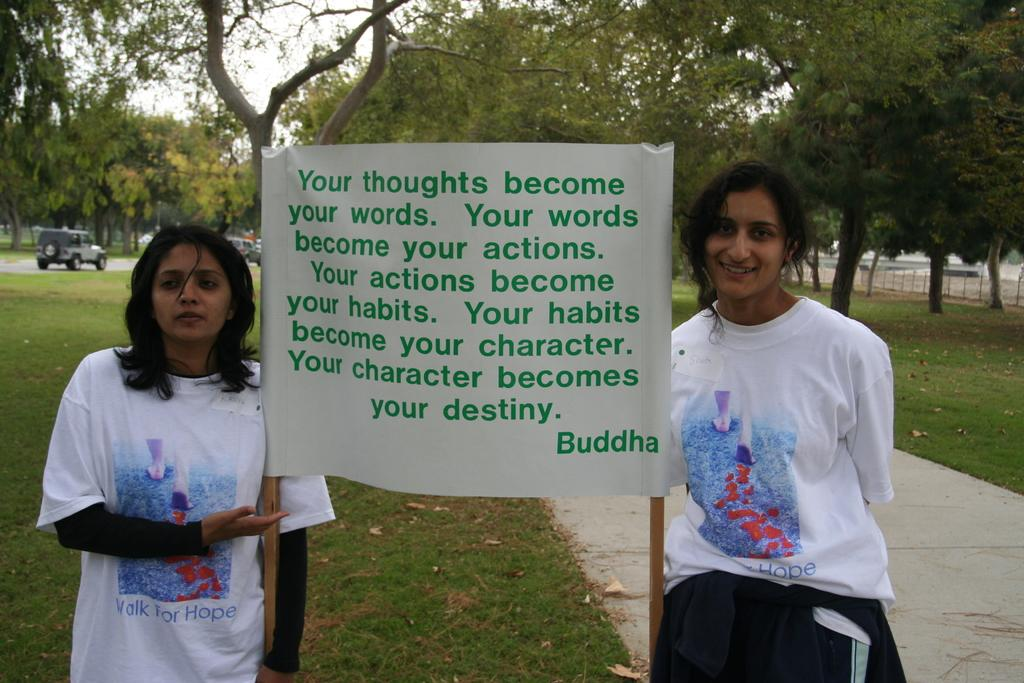<image>
Present a compact description of the photo's key features. Two woman hold a sign with a quote from Buddha in a park. 